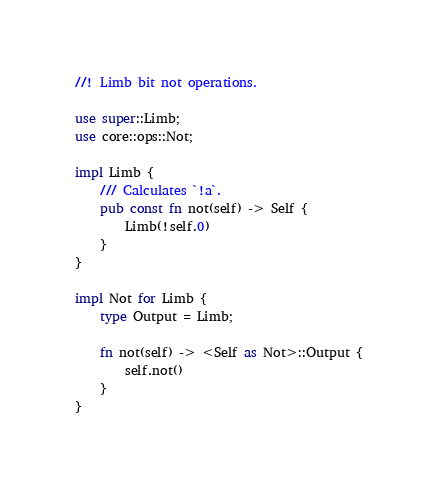<code> <loc_0><loc_0><loc_500><loc_500><_Rust_>//! Limb bit not operations.

use super::Limb;
use core::ops::Not;

impl Limb {
    /// Calculates `!a`.
    pub const fn not(self) -> Self {
        Limb(!self.0)
    }
}

impl Not for Limb {
    type Output = Limb;

    fn not(self) -> <Self as Not>::Output {
        self.not()
    }
}
</code> 